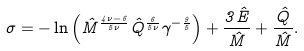Convert formula to latex. <formula><loc_0><loc_0><loc_500><loc_500>\sigma = - \ln { \left ( \hat { M } ^ { \frac { 4 \nu - 6 } { 5 \nu } } \hat { Q } ^ { \frac { 6 } { 5 \nu } } \gamma ^ { - \frac { 9 } { 5 } } \right ) } + \frac { 3 \hat { E } } { \hat { M } } + \frac { \hat { Q } } { \hat { M } } .</formula> 